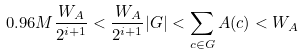<formula> <loc_0><loc_0><loc_500><loc_500>0 . 9 6 M \frac { W _ { A } } { 2 ^ { i + 1 } } < \frac { W _ { A } } { 2 ^ { i + 1 } } | G | < \sum _ { c \in G } A ( c ) < W _ { A }</formula> 